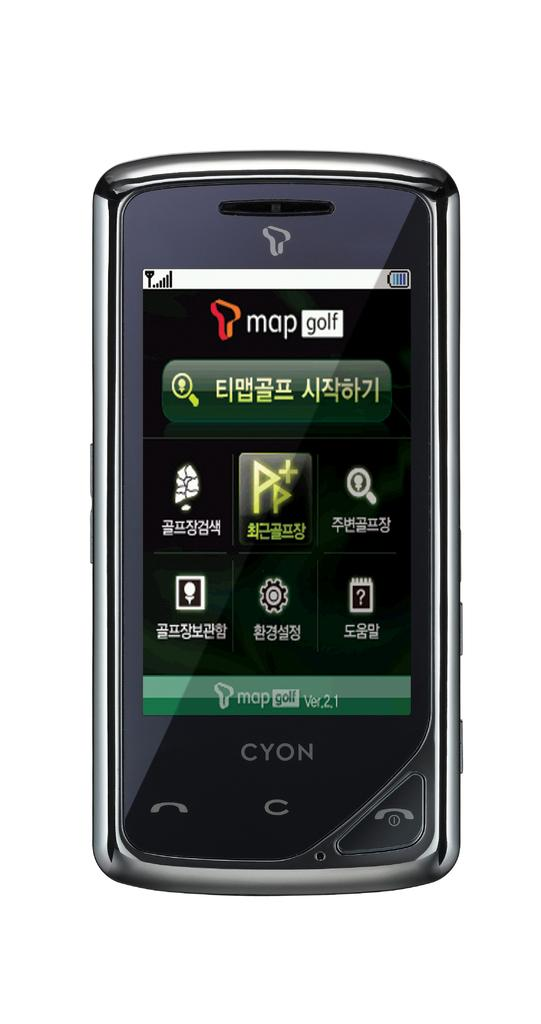<image>
Render a clear and concise summary of the photo. A cyon phone with mapgolf in different language on the phone 